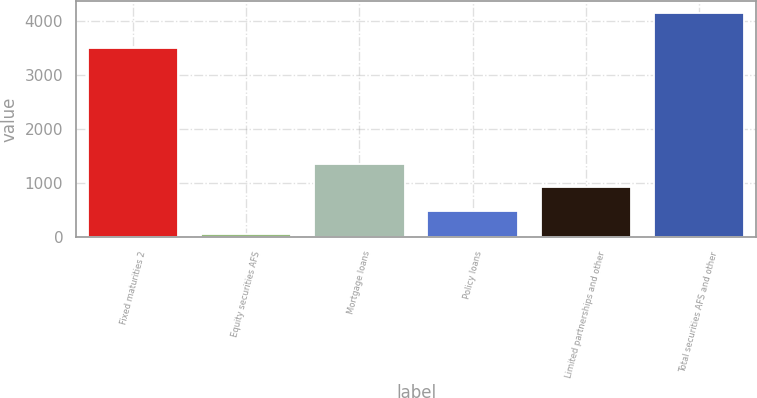Convert chart to OTSL. <chart><loc_0><loc_0><loc_500><loc_500><bar_chart><fcel>Fixed maturities 2<fcel>Equity securities AFS<fcel>Mortgage loans<fcel>Policy loans<fcel>Limited partnerships and other<fcel>Total securities AFS and other<nl><fcel>3489<fcel>53<fcel>1346.3<fcel>484.1<fcel>915.2<fcel>4148<nl></chart> 